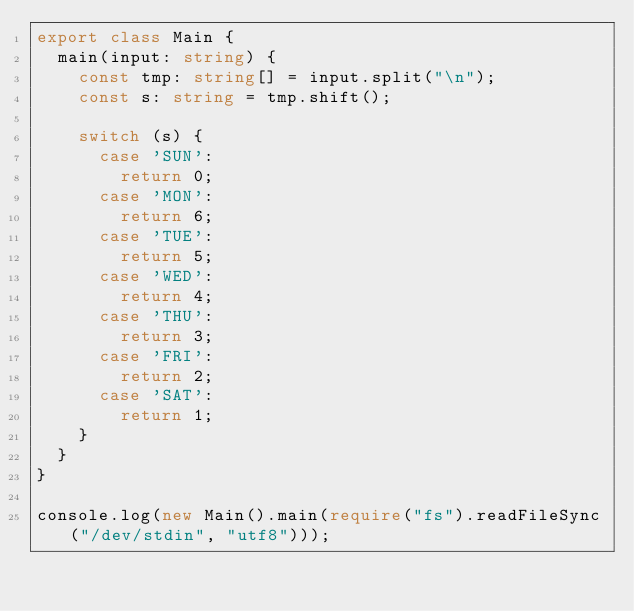<code> <loc_0><loc_0><loc_500><loc_500><_TypeScript_>export class Main {
  main(input: string) {
    const tmp: string[] = input.split("\n");
    const s: string = tmp.shift();

    switch (s) {
      case 'SUN':
        return 0;
      case 'MON':
        return 6;
      case 'TUE':
        return 5;
      case 'WED':
        return 4;
      case 'THU':
        return 3;
      case 'FRI':
        return 2;
      case 'SAT':
        return 1;
    }
  }
}

console.log(new Main().main(require("fs").readFileSync("/dev/stdin", "utf8")));</code> 